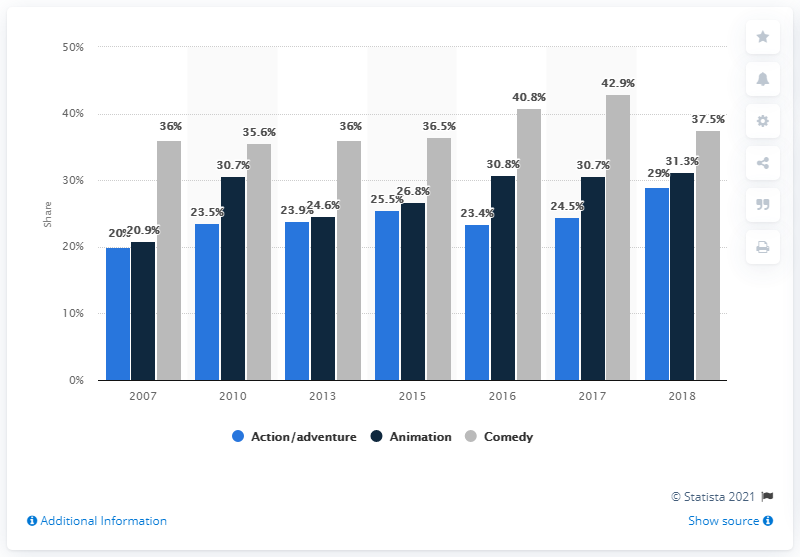Point out several critical features in this image. The color grey is often associated with the emotions of sadness, solemnity, and melancholy, and can indicate the presence of somber or serious content, such as the comedic genre. In 2018, only 29% of roles in action/adventure films were occupied by women. The action/adventure category has the least average value over the years. According to data, in comedy movies, only 37.5% of speaking characters are women. In 2017, only 24.5% of roles in action/adventure films were occupied by women. 